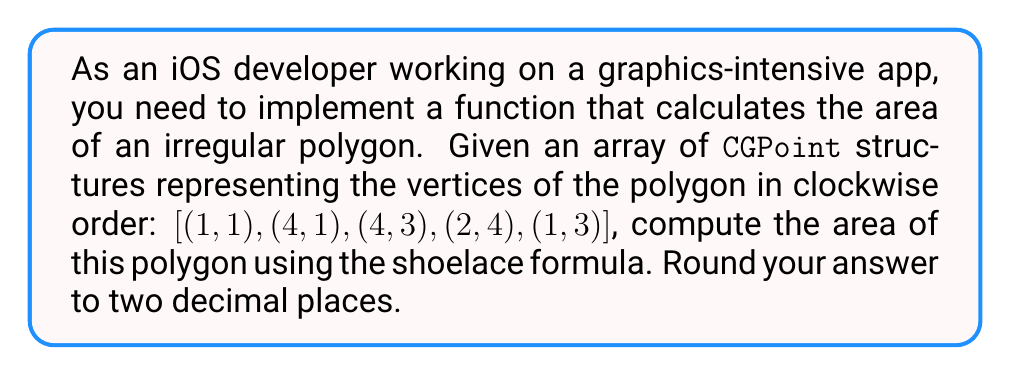Can you answer this question? To solve this problem, we'll use the shoelace formula (also known as the surveyor's formula) to calculate the area of the irregular polygon. The steps are as follows:

1. Shoelace formula:
   $$A = \frac{1}{2}\left|\sum_{i=1}^{n-1} (x_iy_{i+1} - x_{i+1}y_i) + (x_ny_1 - x_1y_n)\right|$$
   where $(x_i, y_i)$ are the coordinates of the $i$-th vertex.

2. Given vertices:
   $(x_1, y_1) = (1, 1)$
   $(x_2, y_2) = (4, 1)$
   $(x_3, y_3) = (4, 3)$
   $(x_4, y_4) = (2, 4)$
   $(x_5, y_5) = (1, 3)$

3. Calculate each term in the summation:
   $(x_1y_2 - x_2y_1) = 1(1) - 4(1) = -3$
   $(x_2y_3 - x_3y_2) = 4(3) - 4(1) = 8$
   $(x_3y_4 - x_4y_3) = 4(4) - 2(3) = 10$
   $(x_4y_5 - x_5y_4) = 2(3) - 1(4) = 2$
   $(x_5y_1 - x_1y_5) = 1(1) - 1(3) = -2$

4. Sum the terms:
   $\sum = -3 + 8 + 10 + 2 - 2 = 15$

5. Apply the formula:
   $$A = \frac{1}{2}|15| = 7.5$$

6. Round to two decimal places: 7.50

[asy]
unitsize(30);
draw((1,1)--(4,1)--(4,3)--(2,4)--(1,3)--cycle);
dot((1,1)); dot((4,1)); dot((4,3)); dot((2,4)); dot((1,3));
label("(1,1)", (1,1), SW);
label("(4,1)", (4,1), SE);
label("(4,3)", (4,3), NE);
label("(2,4)", (2,4), N);
label("(1,3)", (1,3), NW);
[/asy]
Answer: 7.50 square units 